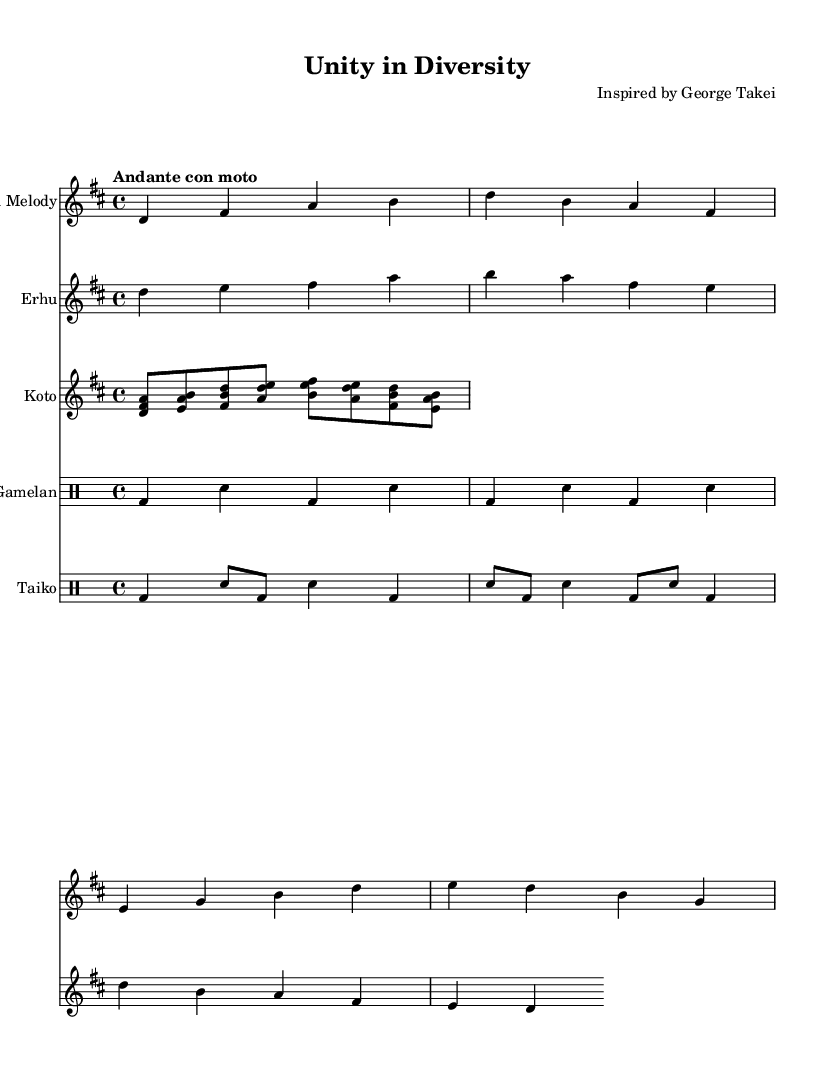What is the key signature of this music? The key signature is D major, which has two sharps (F# and C#). This can be identified from the key signature indicated at the beginning of the score.
Answer: D major What is the time signature of this music? The time signature is 4/4, which can be found at the beginning of the score next to the key signature. It indicates four beats in a measure and that a quarter note receives one beat.
Answer: 4/4 What is the tempo marking of this music? The tempo marking is "Andante con moto," which specifies the speed of the piece. This marking is located above the staff at the beginning of the score.
Answer: Andante con moto How many measures are in the main melody? The main melody consists of 8 measures, as counted by identifying the bars in the main melody staff. Each grouping of notes separated by vertical lines represents a measure.
Answer: 8 What instruments are featured in this piece? The piece features the following instruments: Main Melody, Erhu, Koto, Gamelan, and Taiko. This can be determined by the instrument names listed at the beginning of each staff.
Answer: Main Melody, Erhu, Koto, Gamelan, Taiko What type of rhythm does the Gamelan have? The Gamelan plays a repetitive ostinato rhythm, as indicated by the repeating patterns in the drum staff. An ostinato is characterized by a constant rhythmic or melodic pattern throughout a piece.
Answer: Ostinato How does the Erhu melody relate to the main melody? The Erhu melody generally complements the main melody by providing harmonies that harmonize with the main melodic line. The intervals and notes chosen create a dialogue between the two melodic elements.
Answer: Complements harmonically 